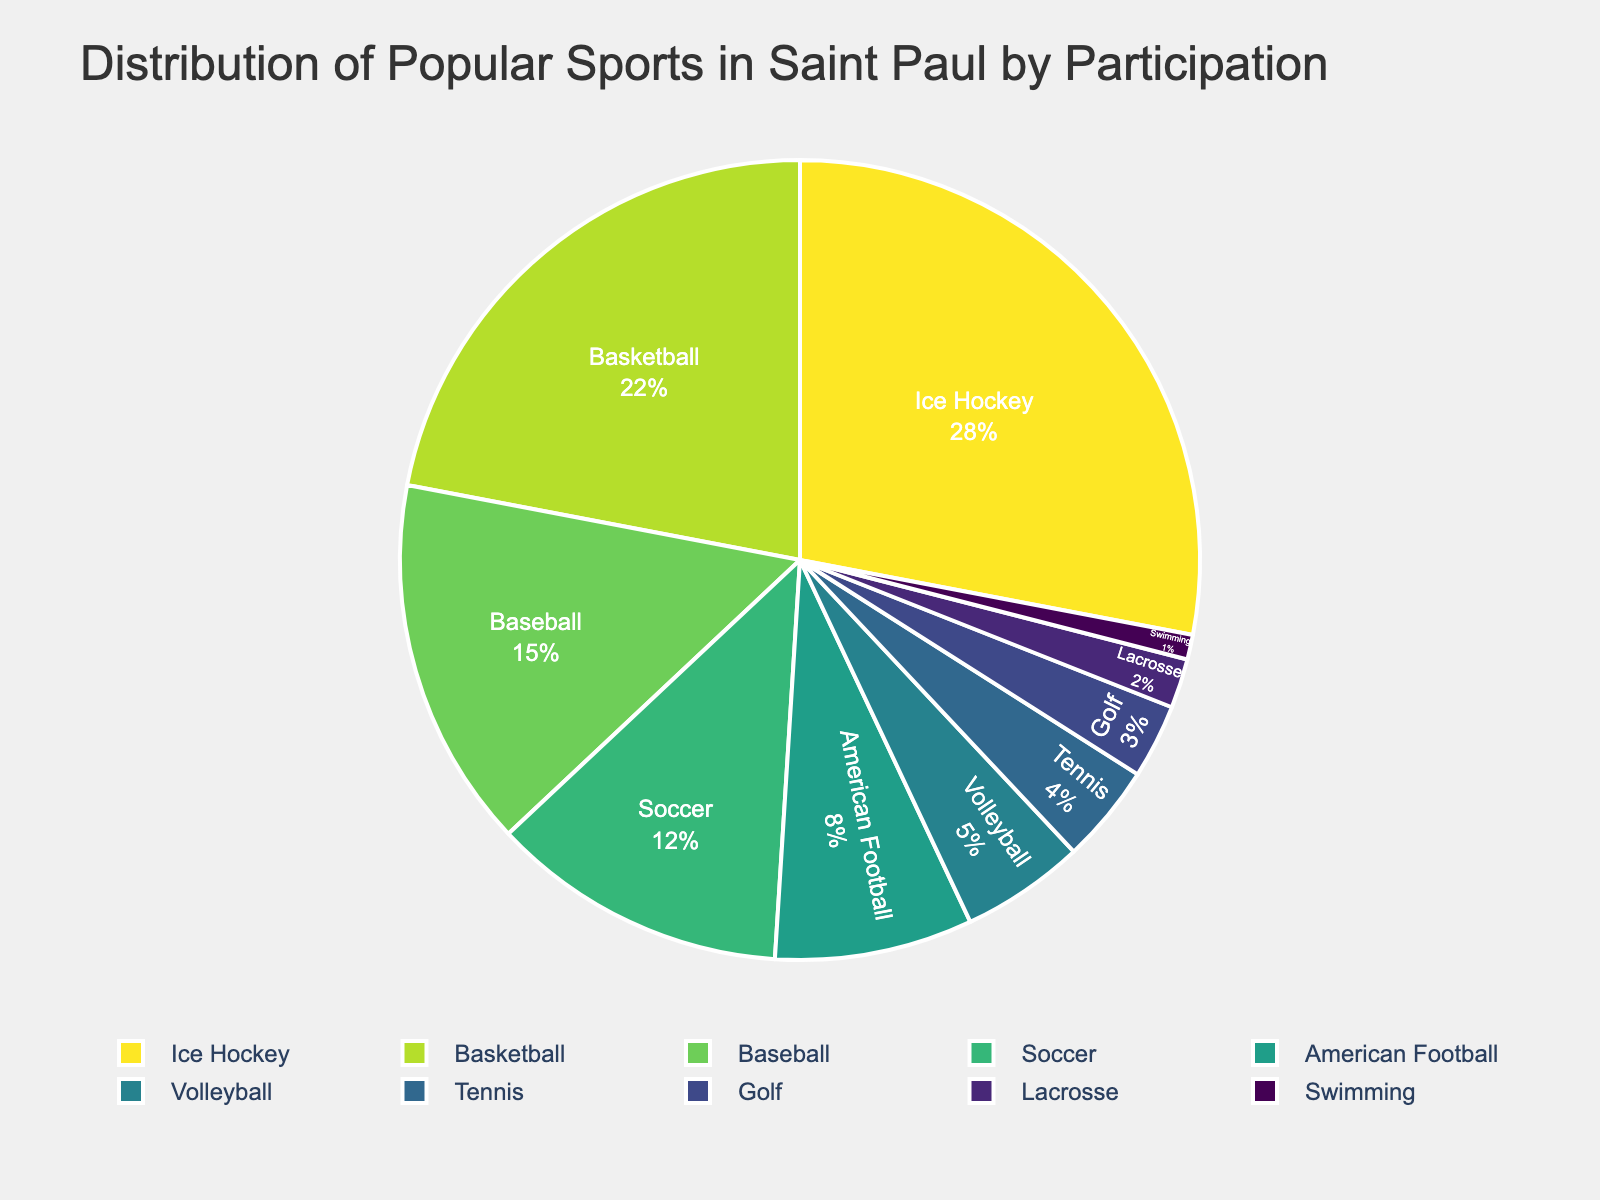Which sport has the highest participation percentage in Saint Paul? Identify the sport with the largest segment in the pie chart, which would be the one occupying the largest area.
Answer: Ice Hockey Which sport has a higher participation percentage: Soccer or Volleyball? Compare the segments corresponding to Soccer and Volleyball. Soccer's segment is larger than Volleyball's.
Answer: Soccer What is the total participation percentage for the top three sports? Add the participation percentages for the top three sports: Ice Hockey (28%), Basketball (22%), and Baseball (15%). 28 + 22 + 15 = 65%.
Answer: 65% Which sport has a participation percentage closest to 10%? Identify the sport whose segment is closest to 10%. Soccer has a participation percentage of 12%, which is closest to 10%.
Answer: Soccer What is the combined participation percentage of American Football and Tennis? Add the participation percentages for American Football (8%) and Tennis (4%). 8 + 4 = 12%.
Answer: 12% How much larger is the participation percentage of Basketball compared to Golf? Subtract the participation percentage of Golf (3%) from the participation percentage of Basketball (22%). 22 - 3 = 19%.
Answer: 19% Are there any sports with a participation percentage less than 5%? If yes, which ones? Identify the segments of the pie chart that are smaller than 5%. The sports are Tennis (4%), Golf (3%), Lacrosse (2%), and Swimming (1%).
Answer: Tennis, Golf, Lacrosse, Swimming What is the difference in participation percentage between Ice Hockey and the sport with the second-highest participation percentage? Subtract the participation percentage of Basketball (22%) from Ice Hockey (28%). 28 - 22 = 6%.
Answer: 6% What percentage of participants engage in sports other than the top four sports? Calculate the sum of participation percentages for sports other than the top four sports (Ice Hockey, Basketball, Baseball, Soccer). The other sports are American Football (8%), Volleyball (5%), Tennis (4%), Golf (3%), Lacrosse (2%), and Swimming (1%). 8 + 5 + 4 + 3 + 2 + 1 = 23%.
Answer: 23% Which sports have a participation percentage greater than or equal to 15%? Identify the segments of the pie chart that are 15% or larger. The sports are Ice Hockey (28%), Basketball (22%), and Baseball (15%).
Answer: Ice Hockey, Basketball, Baseball 